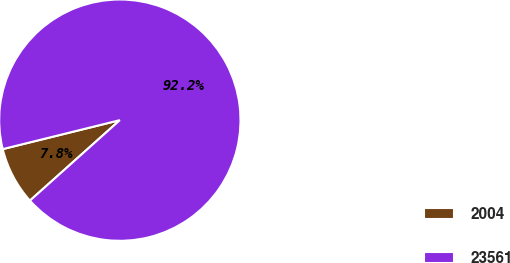Convert chart. <chart><loc_0><loc_0><loc_500><loc_500><pie_chart><fcel>2004<fcel>23561<nl><fcel>7.76%<fcel>92.24%<nl></chart> 